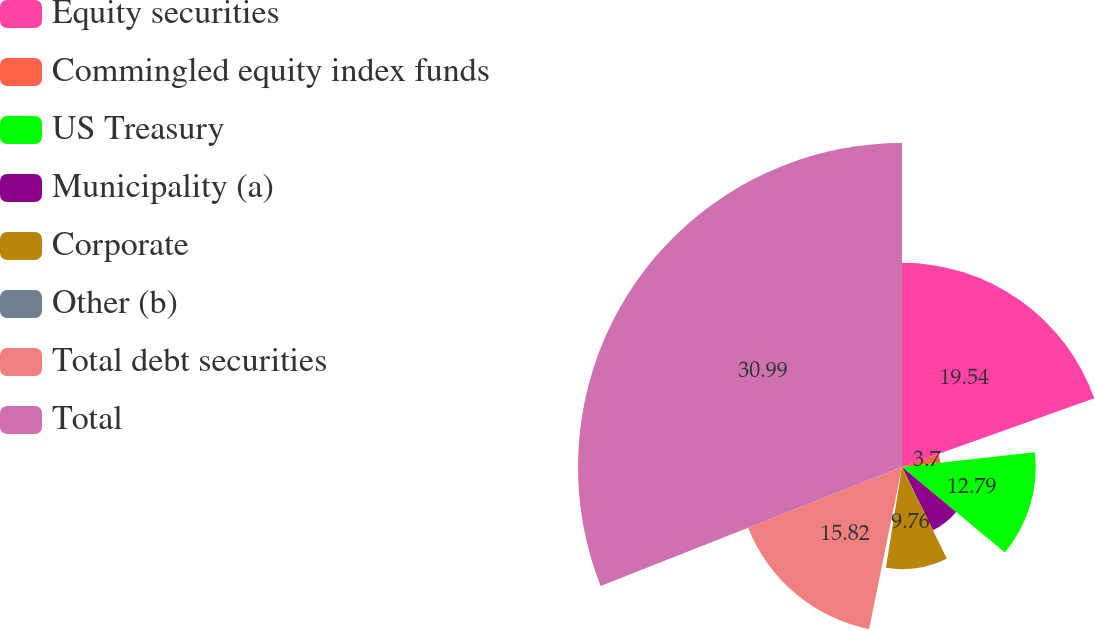Convert chart. <chart><loc_0><loc_0><loc_500><loc_500><pie_chart><fcel>Equity securities<fcel>Commingled equity index funds<fcel>US Treasury<fcel>Municipality (a)<fcel>Corporate<fcel>Other (b)<fcel>Total debt securities<fcel>Total<nl><fcel>19.53%<fcel>3.7%<fcel>12.79%<fcel>6.73%<fcel>9.76%<fcel>0.67%<fcel>15.82%<fcel>30.98%<nl></chart> 